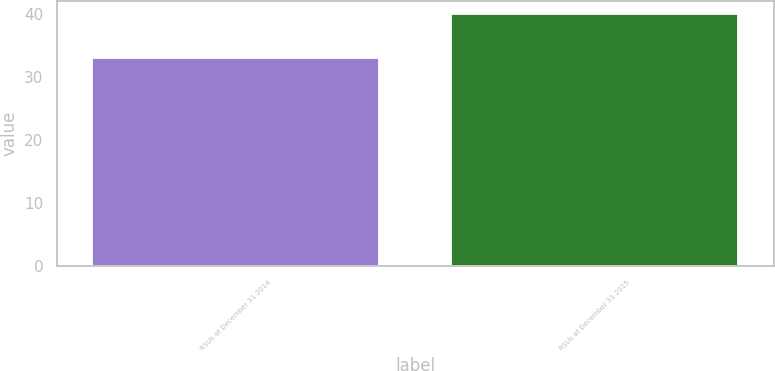Convert chart. <chart><loc_0><loc_0><loc_500><loc_500><bar_chart><fcel>RSUs at December 31 2014<fcel>RSUs at December 31 2015<nl><fcel>32.92<fcel>39.97<nl></chart> 